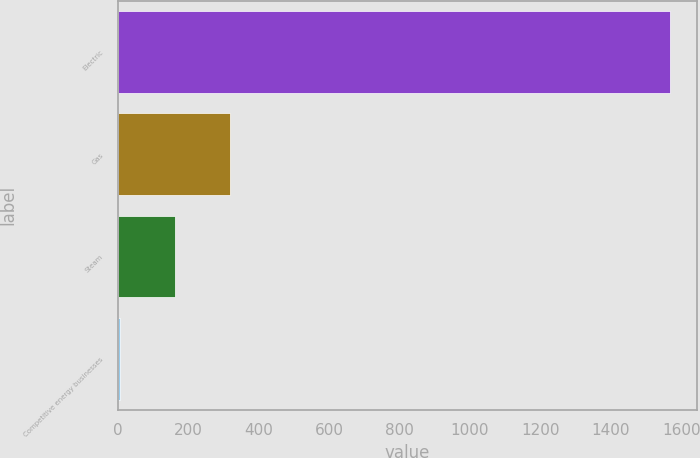Convert chart to OTSL. <chart><loc_0><loc_0><loc_500><loc_500><bar_chart><fcel>Electric<fcel>Gas<fcel>Steam<fcel>Competitive energy businesses<nl><fcel>1567<fcel>319<fcel>163<fcel>7<nl></chart> 